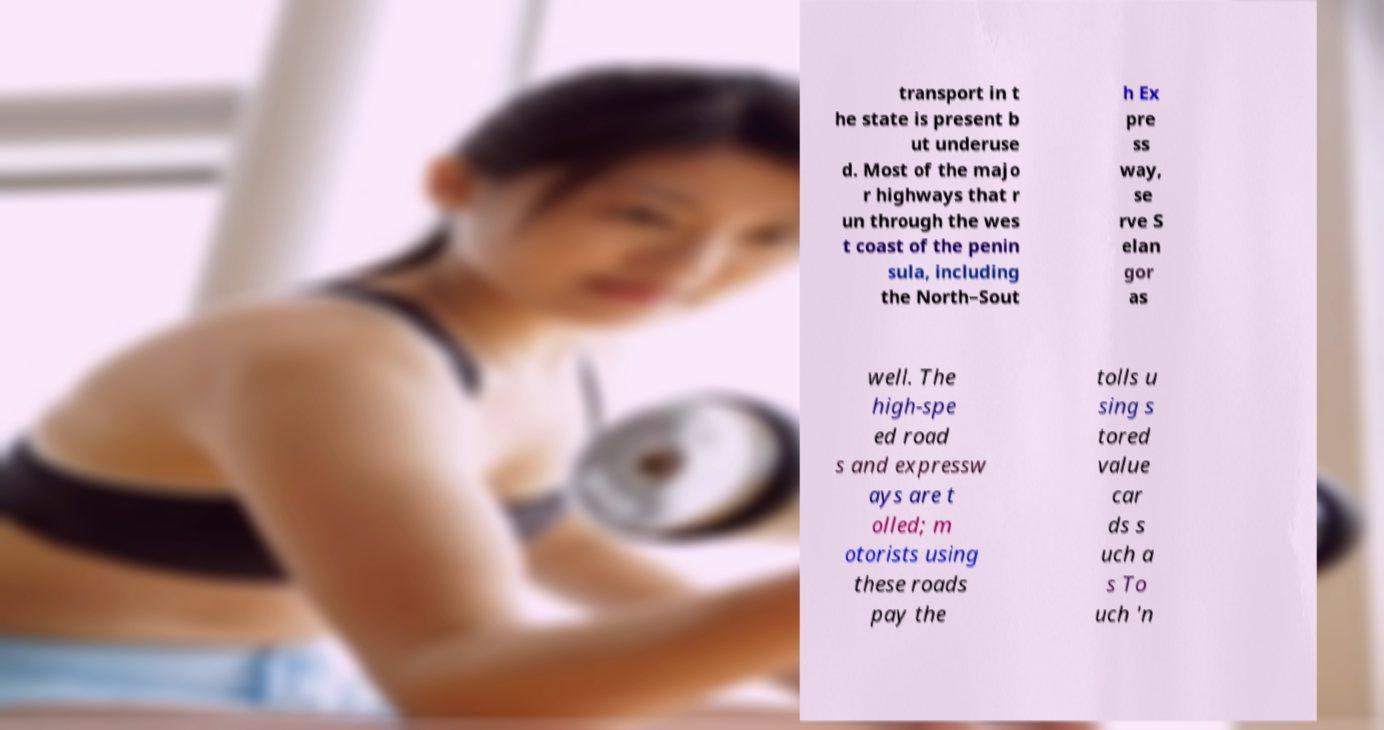Can you read and provide the text displayed in the image?This photo seems to have some interesting text. Can you extract and type it out for me? transport in t he state is present b ut underuse d. Most of the majo r highways that r un through the wes t coast of the penin sula, including the North–Sout h Ex pre ss way, se rve S elan gor as well. The high-spe ed road s and expressw ays are t olled; m otorists using these roads pay the tolls u sing s tored value car ds s uch a s To uch 'n 